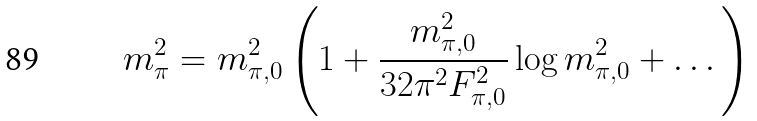<formula> <loc_0><loc_0><loc_500><loc_500>m _ { \pi } ^ { 2 } = m _ { \pi , 0 } ^ { 2 } \left ( 1 + \frac { m _ { \pi , 0 } ^ { 2 } } { 3 2 \pi ^ { 2 } F _ { \pi , 0 } ^ { 2 } } \log m _ { \pi , 0 } ^ { 2 } + \dots \right ) \,</formula> 